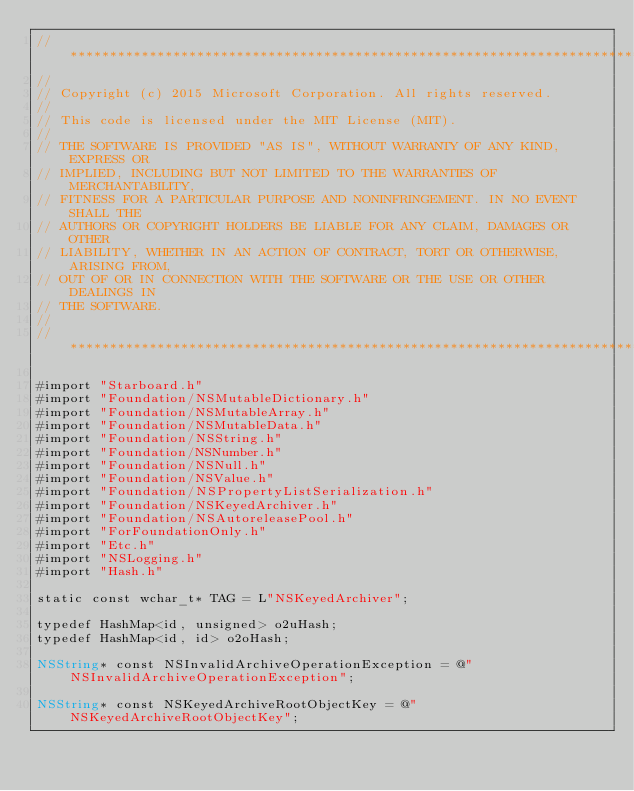<code> <loc_0><loc_0><loc_500><loc_500><_ObjectiveC_>//******************************************************************************
//
// Copyright (c) 2015 Microsoft Corporation. All rights reserved.
//
// This code is licensed under the MIT License (MIT).
//
// THE SOFTWARE IS PROVIDED "AS IS", WITHOUT WARRANTY OF ANY KIND, EXPRESS OR
// IMPLIED, INCLUDING BUT NOT LIMITED TO THE WARRANTIES OF MERCHANTABILITY,
// FITNESS FOR A PARTICULAR PURPOSE AND NONINFRINGEMENT. IN NO EVENT SHALL THE
// AUTHORS OR COPYRIGHT HOLDERS BE LIABLE FOR ANY CLAIM, DAMAGES OR OTHER
// LIABILITY, WHETHER IN AN ACTION OF CONTRACT, TORT OR OTHERWISE, ARISING FROM,
// OUT OF OR IN CONNECTION WITH THE SOFTWARE OR THE USE OR OTHER DEALINGS IN
// THE SOFTWARE.
//
//******************************************************************************

#import "Starboard.h"
#import "Foundation/NSMutableDictionary.h"
#import "Foundation/NSMutableArray.h"
#import "Foundation/NSMutableData.h"
#import "Foundation/NSString.h"
#import "Foundation/NSNumber.h"
#import "Foundation/NSNull.h"
#import "Foundation/NSValue.h"
#import "Foundation/NSPropertyListSerialization.h"
#import "Foundation/NSKeyedArchiver.h"
#import "Foundation/NSAutoreleasePool.h"
#import "ForFoundationOnly.h"
#import "Etc.h"
#import "NSLogging.h"
#import "Hash.h"

static const wchar_t* TAG = L"NSKeyedArchiver";

typedef HashMap<id, unsigned> o2uHash;
typedef HashMap<id, id> o2oHash;

NSString* const NSInvalidArchiveOperationException = @"NSInvalidArchiveOperationException";

NSString* const NSKeyedArchiveRootObjectKey = @"NSKeyedArchiveRootObjectKey";</code> 